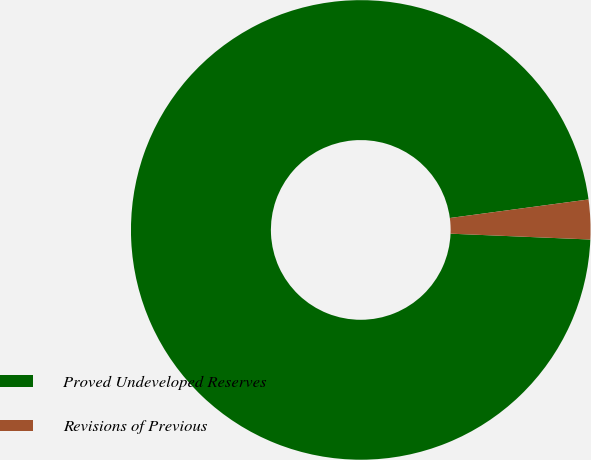<chart> <loc_0><loc_0><loc_500><loc_500><pie_chart><fcel>Proved Undeveloped Reserves<fcel>Revisions of Previous<nl><fcel>97.22%<fcel>2.78%<nl></chart> 